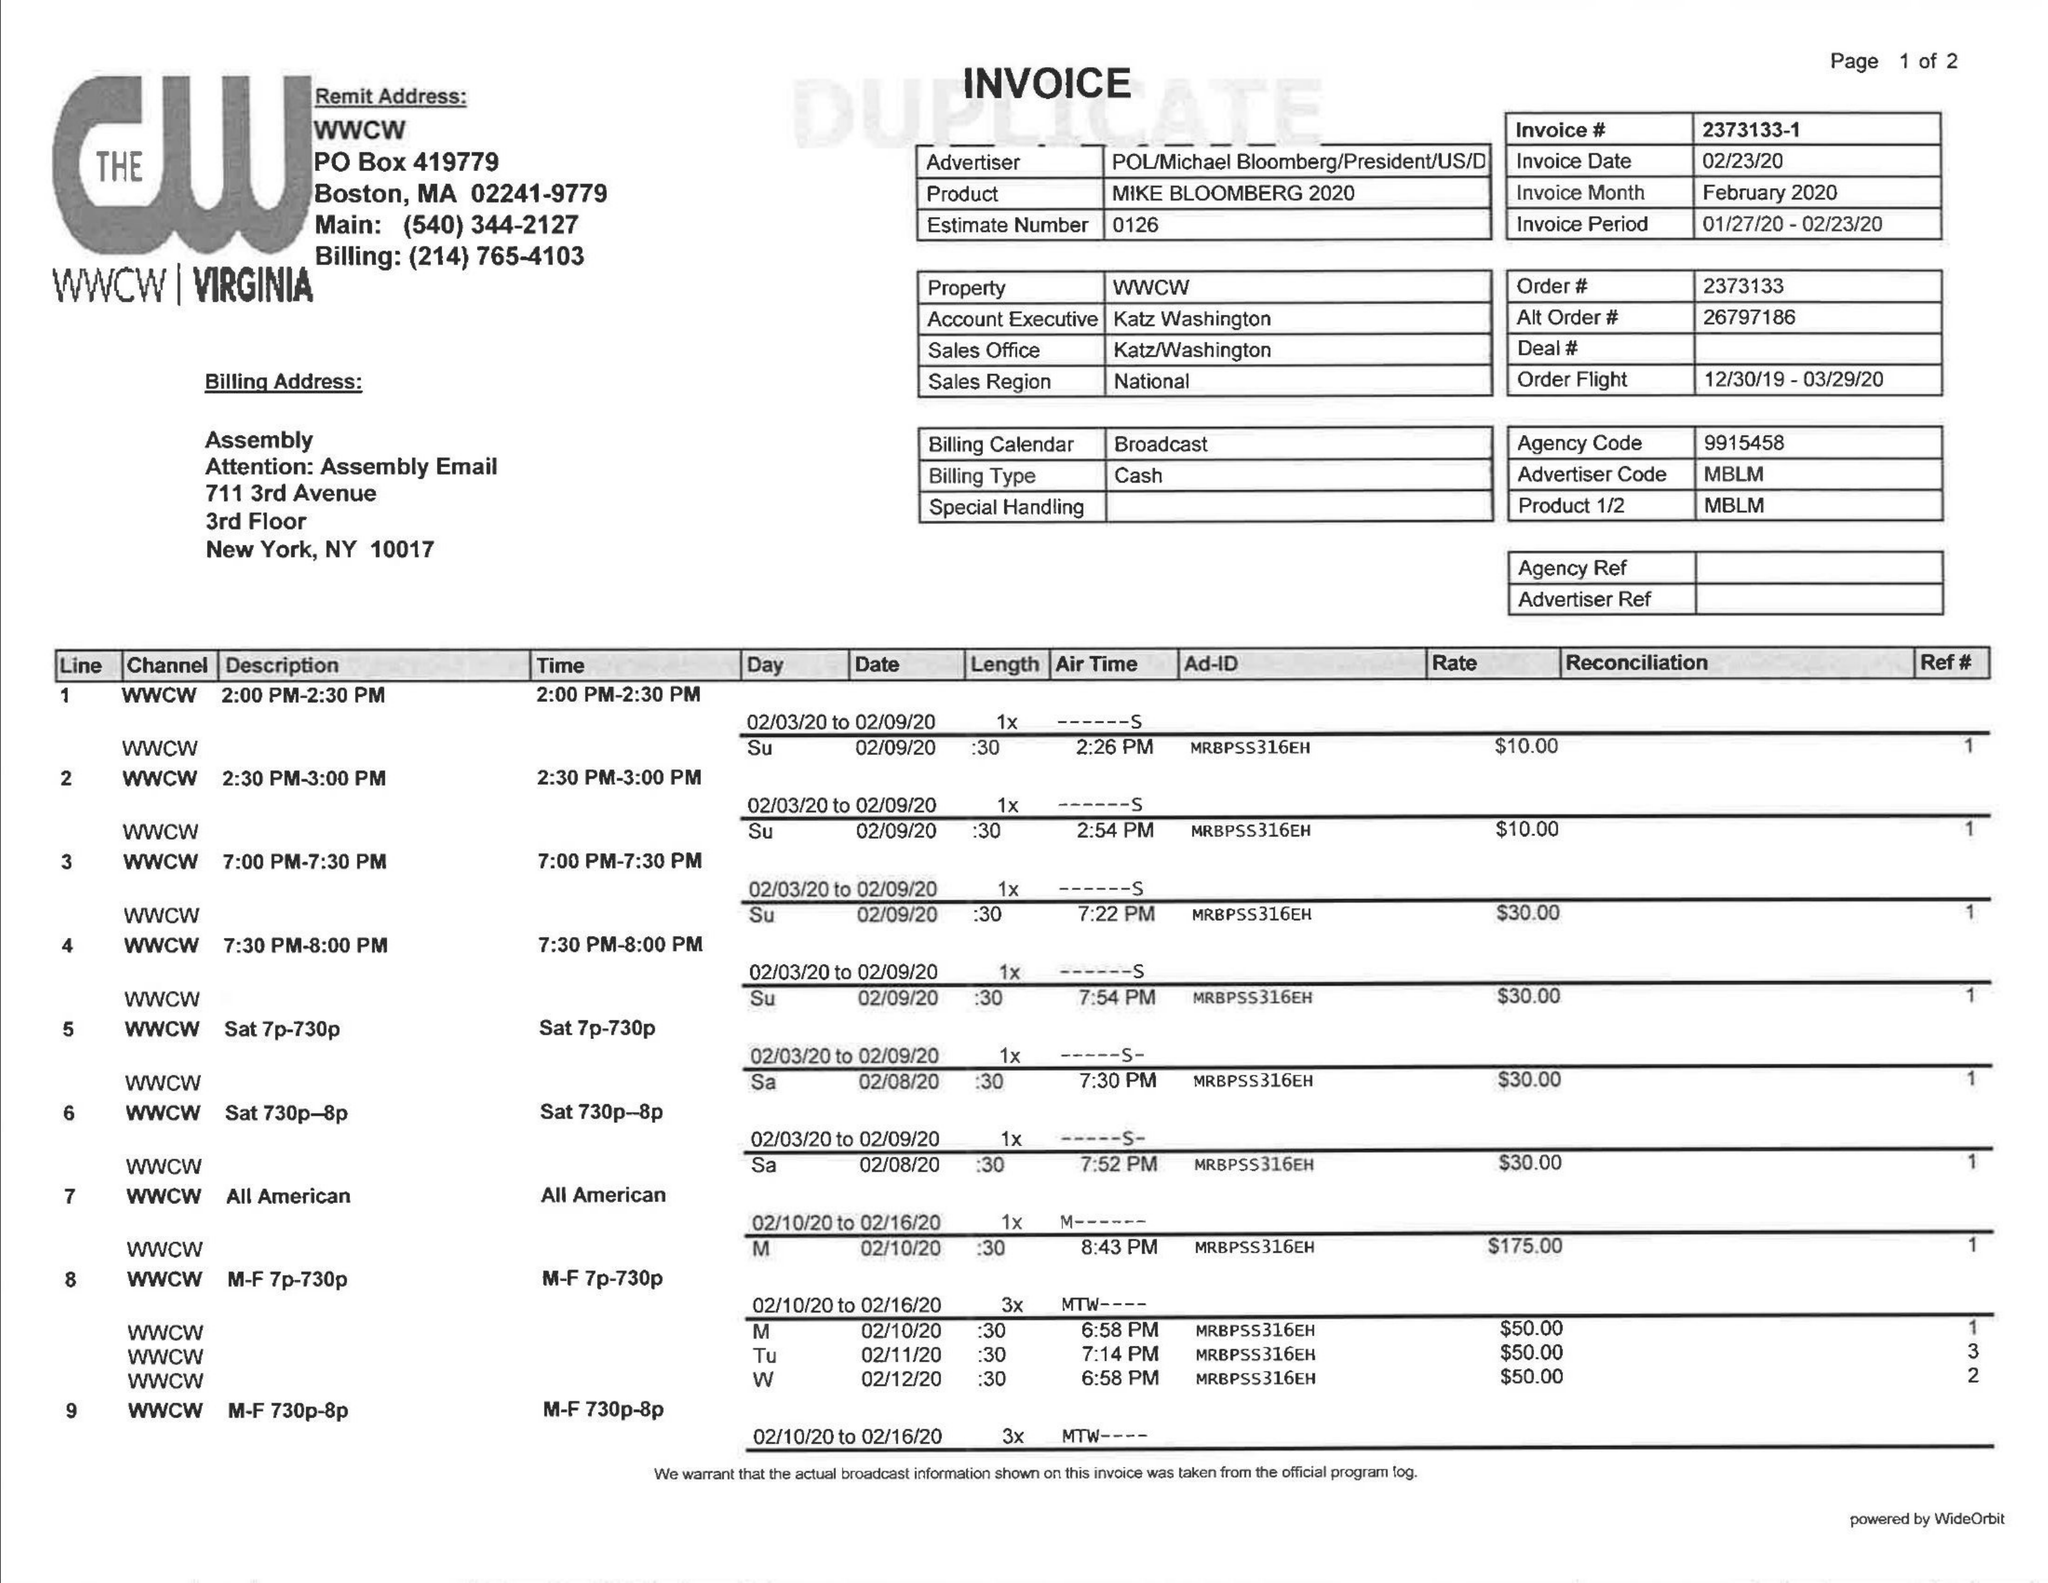What is the value for the contract_num?
Answer the question using a single word or phrase. 2373133 